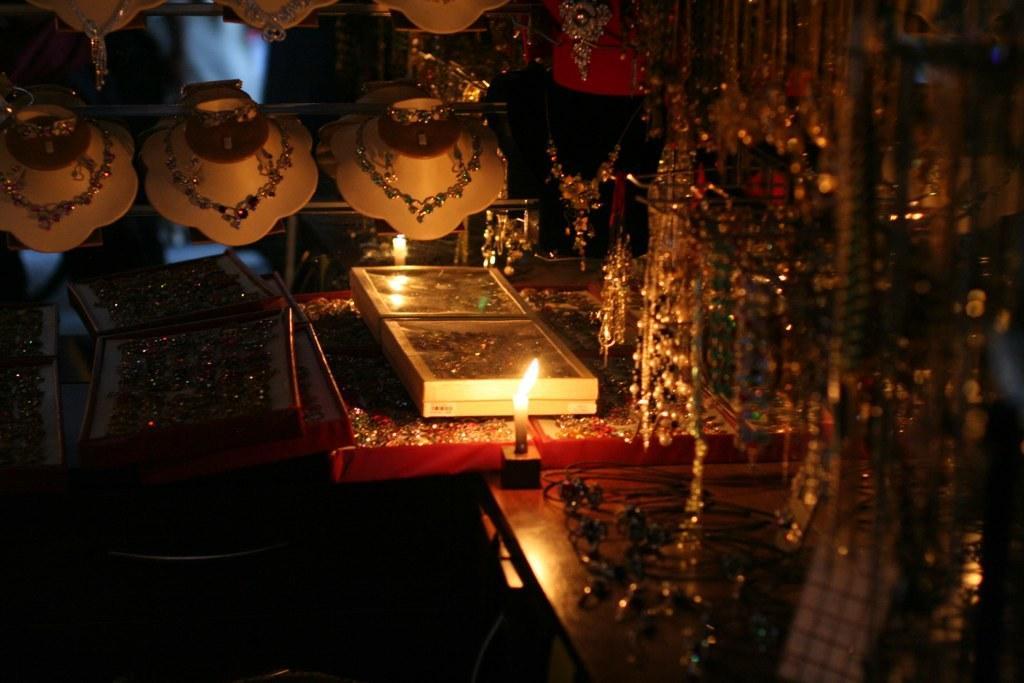How would you summarize this image in a sentence or two? In this image, we can see some jewelry. Among them, we can see some necklaces on necklace holders. We can also see some ornaments in boxes. We can see a table with some objects and a candle. 